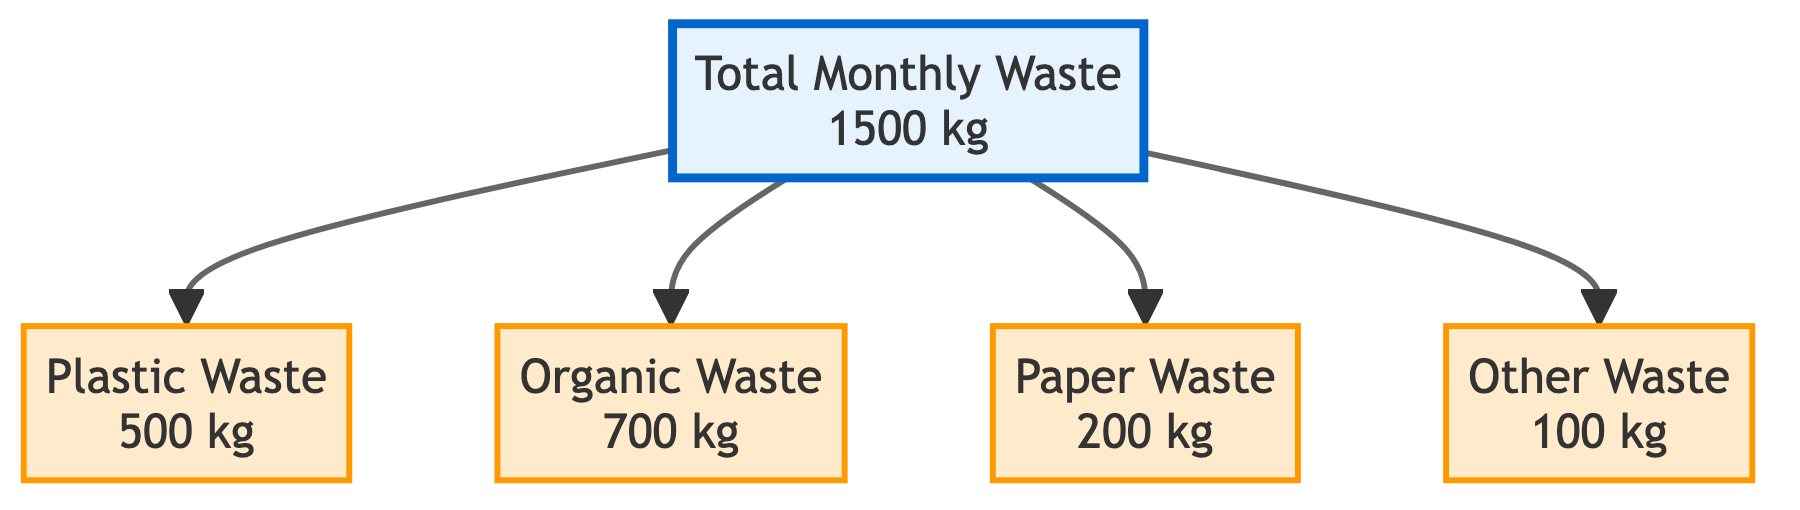What is the total monthly waste production? The diagram indicates that the total monthly waste is depicted in the "Total Monthly Waste" node, which explicitly states "1500 kg."
Answer: 1500 kg How much plastic waste is produced monthly? The "Plastic Waste" node in the diagram clearly shows "500 kg" of plastic waste, indicating the amount produced each month.
Answer: 500 kg What is the weight of organic waste? By looking at the "Organic Waste" node, we see it specifies "700 kg," which denotes the total weight of organic waste for that month.
Answer: 700 kg How many categories of waste are displayed in the diagram? The diagram includes four categories of waste: plastic, organic, paper, and other, which can be counted from the nodes connected to "Total Monthly Waste."
Answer: 4 Which type of waste has the smallest weight? The "Other Waste" node shows "100 kg," which is less than the weights of the other categories (plastic, organic, and paper).
Answer: Other Waste What is the weight difference between organic waste and paper waste? Organic waste is 700 kg, and paper waste is 200 kg. The difference between these weights is calculated by subtracting the weight of paper waste from the weight of organic waste (700 kg - 200 kg).
Answer: 500 kg What percentage of the total waste is plastic waste? Plastic waste is 500 kg out of 1500 kg total waste. To find the percentage, divide 500 by 1500 and multiply by 100. The calculation indicates that plastic waste makes up one-third of the total.
Answer: 33.33% What is the sum of the weights of paper waste and other waste? The "Paper Waste" node shows "200 kg," and the "Other Waste" node shows "100 kg." Adding these two weights together gives the combined total waste amount represented by these two categories.
Answer: 300 kg How does the weight of plastic waste compare to organic waste? Plastic waste is 500 kg, and organic waste is 700 kg. By comparing these weights, it can be noted that organic waste is heavier than plastic waste.
Answer: Organic Waste is heavier 